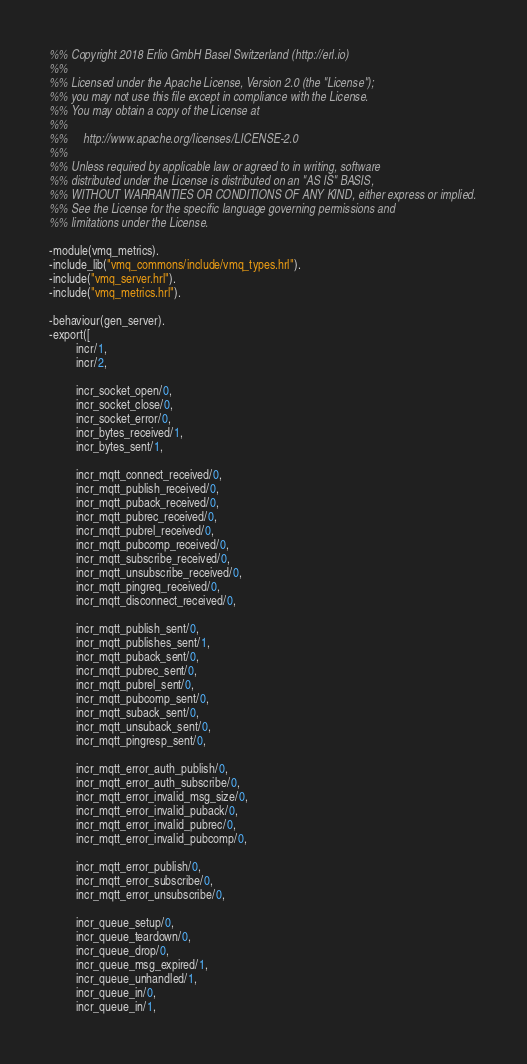Convert code to text. <code><loc_0><loc_0><loc_500><loc_500><_Erlang_>%% Copyright 2018 Erlio GmbH Basel Switzerland (http://erl.io)
%%
%% Licensed under the Apache License, Version 2.0 (the "License");
%% you may not use this file except in compliance with the License.
%% You may obtain a copy of the License at
%%
%%     http://www.apache.org/licenses/LICENSE-2.0
%%
%% Unless required by applicable law or agreed to in writing, software
%% distributed under the License is distributed on an "AS IS" BASIS,
%% WITHOUT WARRANTIES OR CONDITIONS OF ANY KIND, either express or implied.
%% See the License for the specific language governing permissions and
%% limitations under the License.

-module(vmq_metrics).
-include_lib("vmq_commons/include/vmq_types.hrl").
-include("vmq_server.hrl").
-include("vmq_metrics.hrl").

-behaviour(gen_server).
-export([
         incr/1,
         incr/2,

         incr_socket_open/0,
         incr_socket_close/0,
         incr_socket_error/0,
         incr_bytes_received/1,
         incr_bytes_sent/1,

         incr_mqtt_connect_received/0,
         incr_mqtt_publish_received/0,
         incr_mqtt_puback_received/0,
         incr_mqtt_pubrec_received/0,
         incr_mqtt_pubrel_received/0,
         incr_mqtt_pubcomp_received/0,
         incr_mqtt_subscribe_received/0,
         incr_mqtt_unsubscribe_received/0,
         incr_mqtt_pingreq_received/0,
         incr_mqtt_disconnect_received/0,

         incr_mqtt_publish_sent/0,
         incr_mqtt_publishes_sent/1,
         incr_mqtt_puback_sent/0,
         incr_mqtt_pubrec_sent/0,
         incr_mqtt_pubrel_sent/0,
         incr_mqtt_pubcomp_sent/0,
         incr_mqtt_suback_sent/0,
         incr_mqtt_unsuback_sent/0,
         incr_mqtt_pingresp_sent/0,

         incr_mqtt_error_auth_publish/0,
         incr_mqtt_error_auth_subscribe/0,
         incr_mqtt_error_invalid_msg_size/0,
         incr_mqtt_error_invalid_puback/0,
         incr_mqtt_error_invalid_pubrec/0,
         incr_mqtt_error_invalid_pubcomp/0,

         incr_mqtt_error_publish/0,
         incr_mqtt_error_subscribe/0,
         incr_mqtt_error_unsubscribe/0,

         incr_queue_setup/0,
         incr_queue_teardown/0,
         incr_queue_drop/0,
         incr_queue_msg_expired/1,
         incr_queue_unhandled/1,
         incr_queue_in/0,
         incr_queue_in/1,</code> 